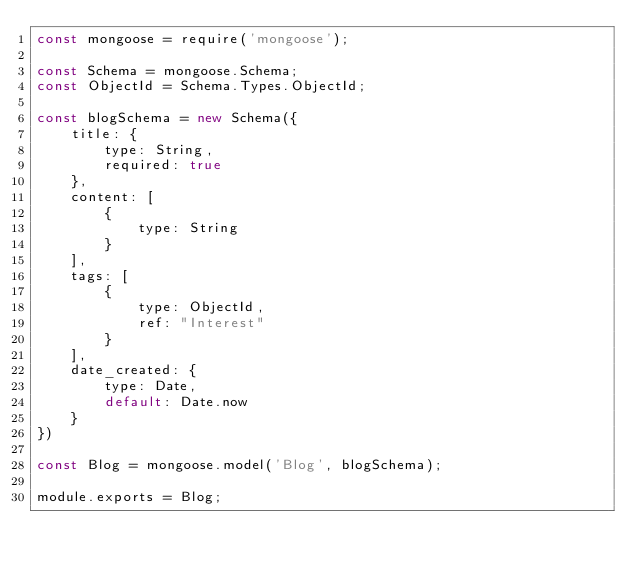Convert code to text. <code><loc_0><loc_0><loc_500><loc_500><_JavaScript_>const mongoose = require('mongoose');

const Schema = mongoose.Schema;
const ObjectId = Schema.Types.ObjectId;

const blogSchema = new Schema({
    title: {
        type: String,
        required: true
    },
    content: [
        {
            type: String
        }
    ],
    tags: [
        {
            type: ObjectId,
            ref: "Interest"
        }
    ],
    date_created: {
        type: Date,
        default: Date.now
    }
})

const Blog = mongoose.model('Blog', blogSchema);

module.exports = Blog;</code> 